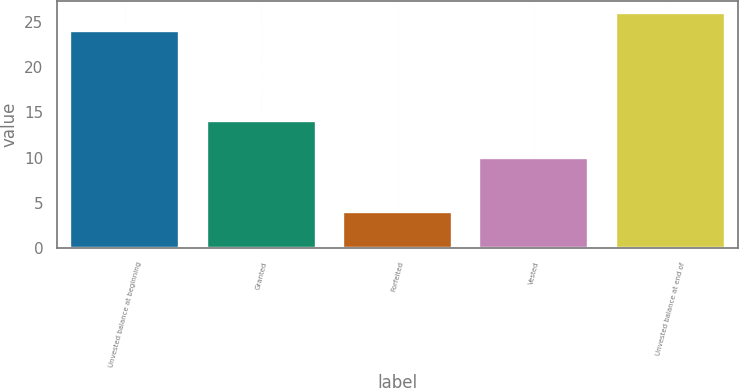<chart> <loc_0><loc_0><loc_500><loc_500><bar_chart><fcel>Unvested balance at beginning<fcel>Granted<fcel>Forfeited<fcel>Vested<fcel>Unvested balance at end of<nl><fcel>24<fcel>14<fcel>4<fcel>10<fcel>26<nl></chart> 